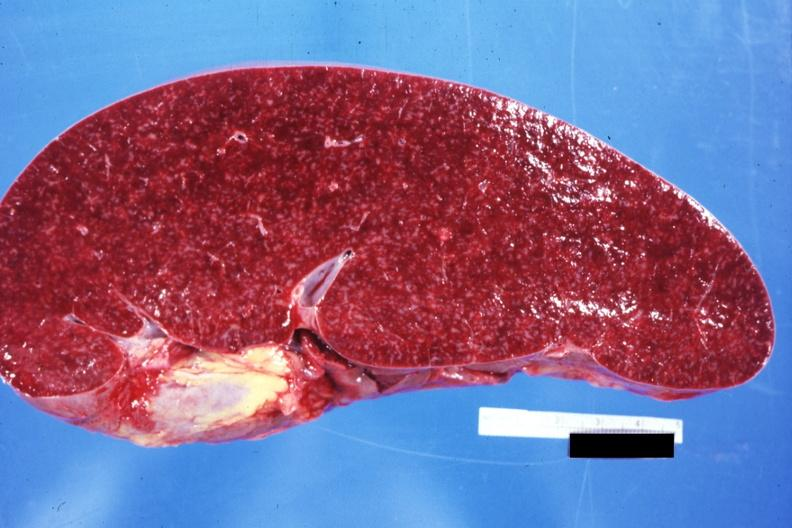does opened base of skull with brain show cut surface prominent lymph follicles size appears normal see other sides this case?
Answer the question using a single word or phrase. No 